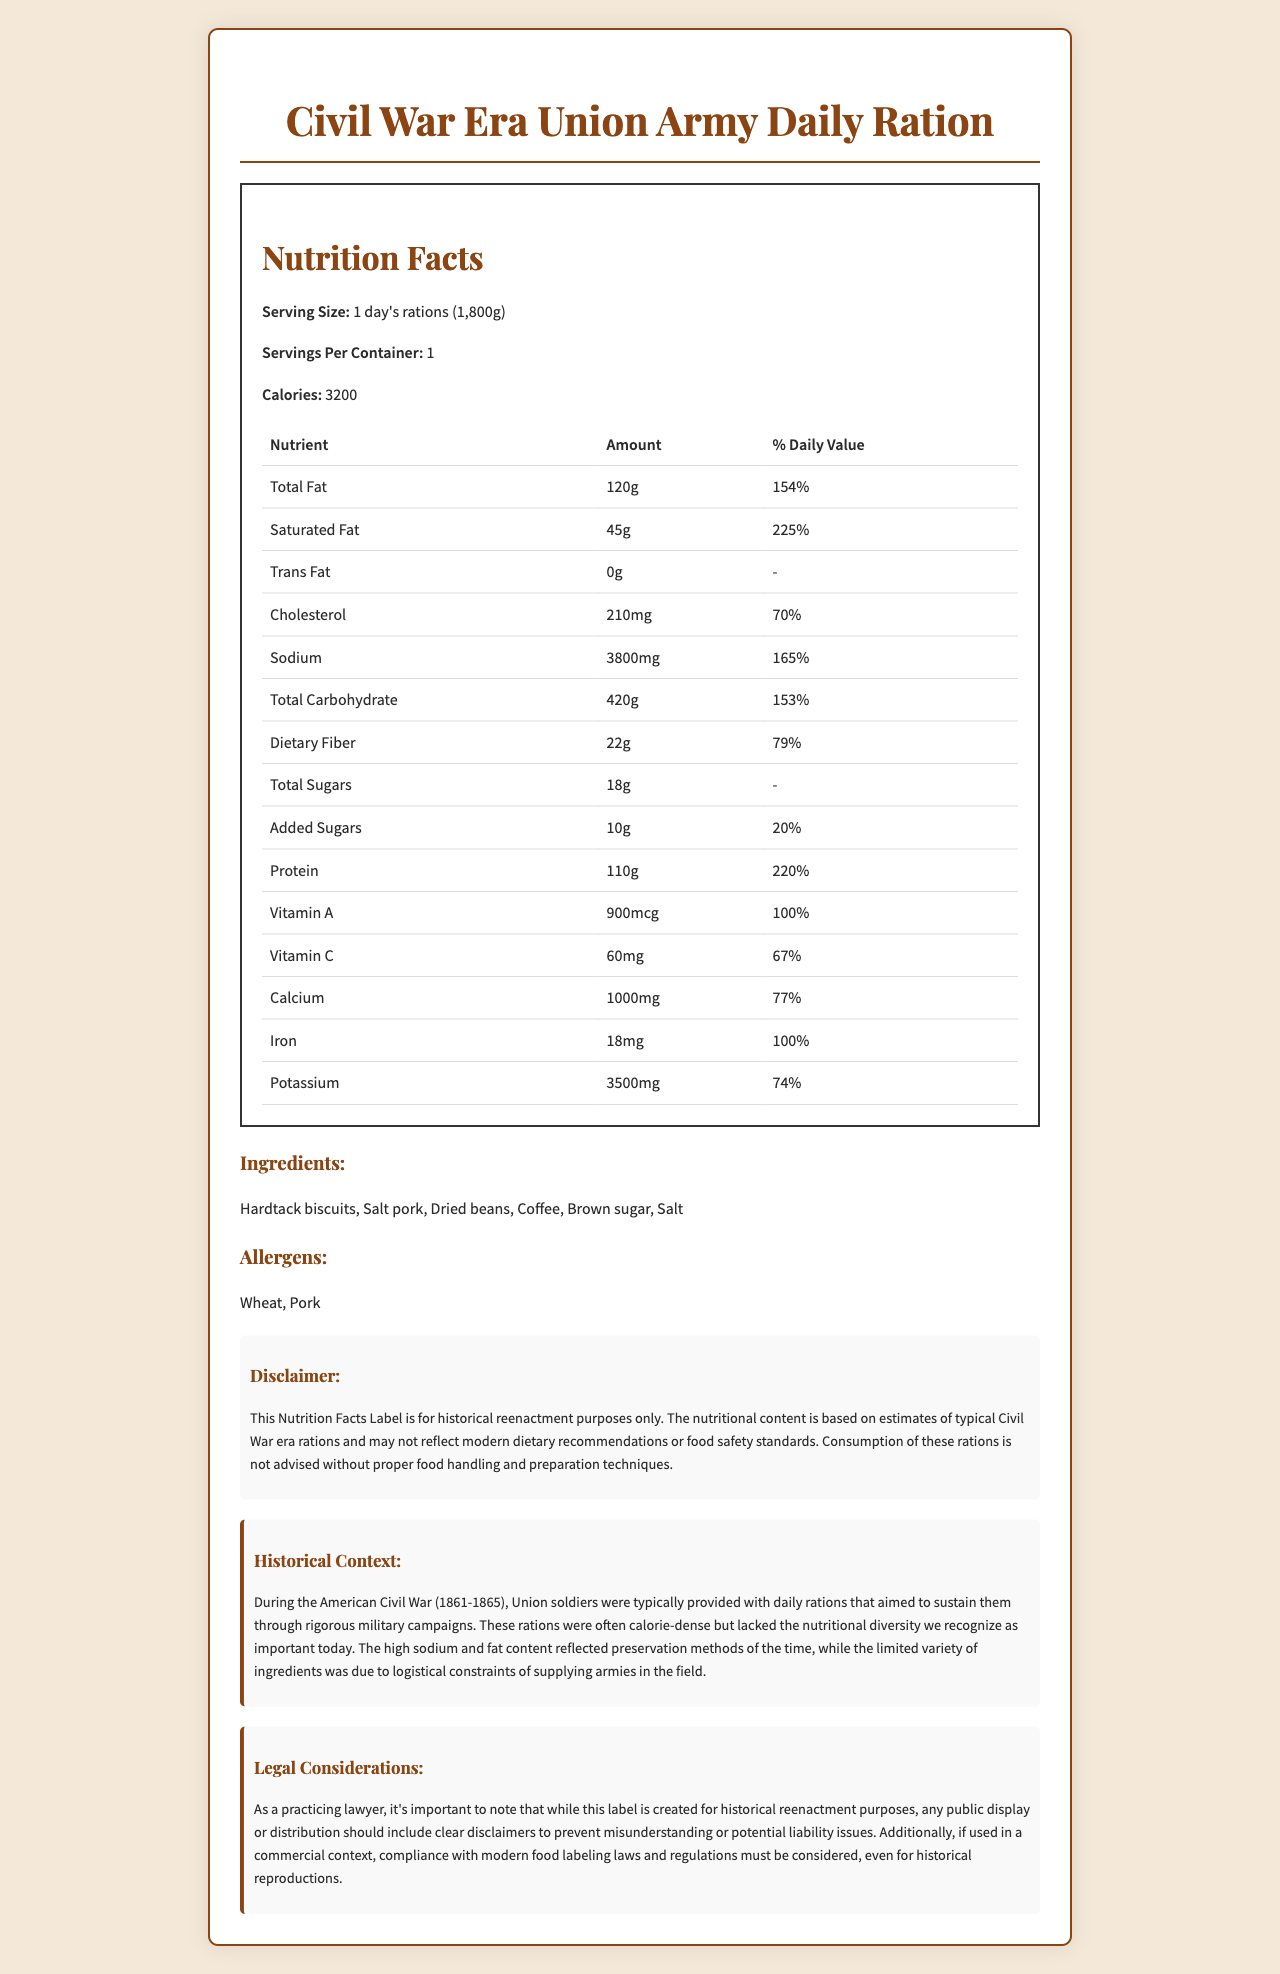what is the serving size for the Civil War Era Union Army Daily Ration? The serving size is clearly stated in the nutrition facts section as "1 day's rations (1,800g)."
Answer: 1 day's rations (1,800g) how many calories are there per serving? The calories per serving are listed as 3200 in the nutrition facts section.
Answer: 3200 what is the total amount of fat in grams? The total fat content is provided as 120g in the nutrition facts table.
Answer: 120g what ingredients are included in the rations? The ingredients list section includes "Hardtack biscuits, Salt pork, Dried beans, Coffee, Brown sugar, Salt."
Answer: Hardtack biscuits, Salt pork, Dried beans, Coffee, Brown sugar, Salt what allergens are present in this ration? The allergens are listed as "Wheat, Pork" under the allergens section.
Answer: Wheat, Pork what is the percentage daily value of saturated fat? The percentage daily value for saturated fat is provided as 225%.
Answer: 225% what nutrient has the highest percentage daily value? A. Total Fat B. Sodium C. Iron D. Protein The nutrient with the highest percentage daily value is Iron, listed at 100%.
Answer: C. Iron which nutrient is not present in this ration? A. Trans Fat B. Vitamin C C. Potassium D. Calcium Trans Fat is listed as 0g, indicating it is not present in the ration.
Answer: A. Trans Fat is there any trans fat in this ration? The nutrition facts table states that Trans Fat is 0g.
Answer: No summarize the entire document The document includes a comprehensive nutrition label detailing the contents and nutritional value of a Civil War Era Union Army Daily Ration, highlighting its historical and legal context, and providing necessary disclaimers regarding its use.
Answer: The document provides the nutrition facts for a Civil War Era Union Army Daily Ration, offering detailed information on serving size, calories, and nutrient content, as well as ingredients and allergens. It includes disclaimers and historical context about the rations provided to Union soldiers during the Civil War, along with legal considerations for public display and commercial use. what was the primary preservation method for these rations? The document mentions that high sodium and fat content reflected preservation methods of the time, but it does not specify what those methods were.
Answer: Not enough information 